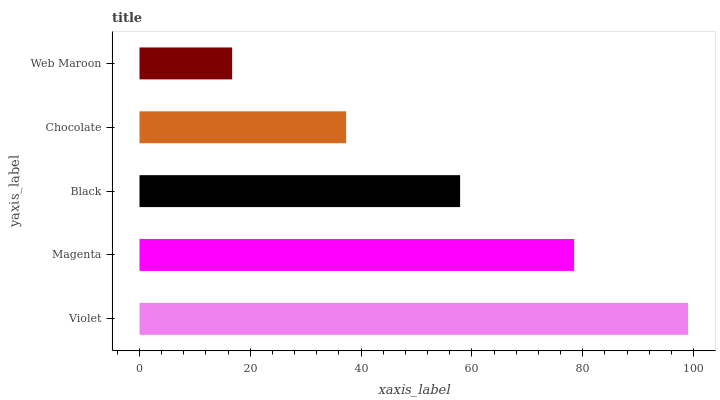Is Web Maroon the minimum?
Answer yes or no. Yes. Is Violet the maximum?
Answer yes or no. Yes. Is Magenta the minimum?
Answer yes or no. No. Is Magenta the maximum?
Answer yes or no. No. Is Violet greater than Magenta?
Answer yes or no. Yes. Is Magenta less than Violet?
Answer yes or no. Yes. Is Magenta greater than Violet?
Answer yes or no. No. Is Violet less than Magenta?
Answer yes or no. No. Is Black the high median?
Answer yes or no. Yes. Is Black the low median?
Answer yes or no. Yes. Is Chocolate the high median?
Answer yes or no. No. Is Chocolate the low median?
Answer yes or no. No. 